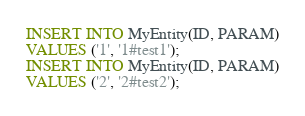Convert code to text. <code><loc_0><loc_0><loc_500><loc_500><_SQL_>INSERT INTO MyEntity(ID, PARAM)
VALUES ('1', '1#test1');
INSERT INTO MyEntity(ID, PARAM)
VALUES ('2', '2#test2');
</code> 